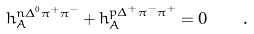Convert formula to latex. <formula><loc_0><loc_0><loc_500><loc_500>h _ { A } ^ { n \Delta ^ { 0 } \pi ^ { + } \pi ^ { - } } + h _ { A } ^ { p \Delta ^ { + } \pi ^ { - } \pi ^ { + } } = 0 \quad .</formula> 